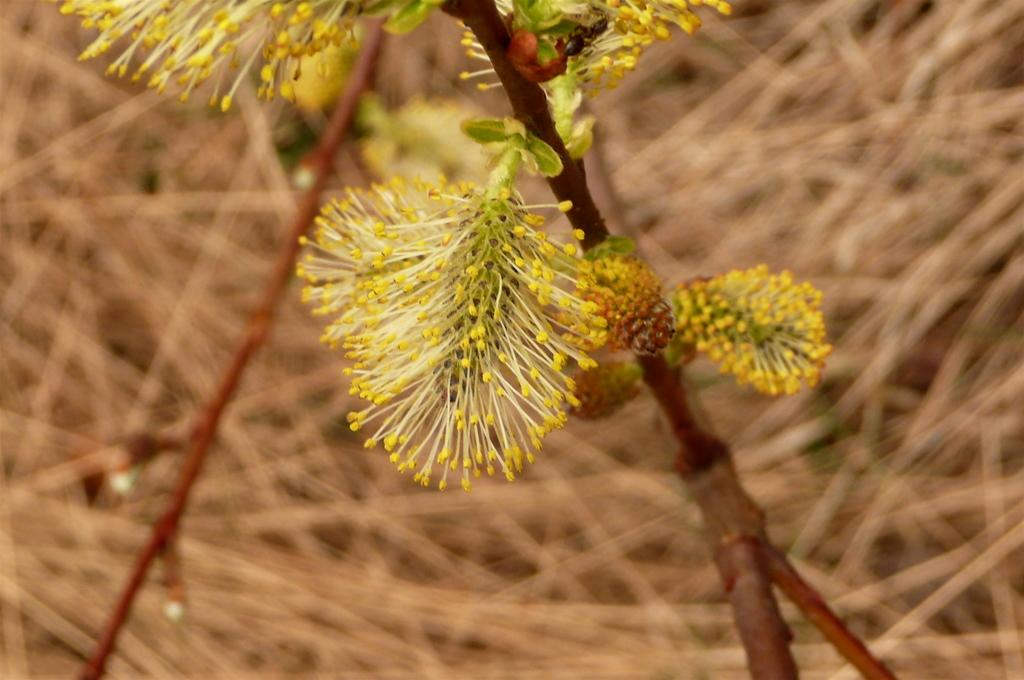What is the main subject of the image? There is a plant in the image. What color are the flowers on the plant? The plant has yellow flowers. Can you describe the background of the image? The background of the image is blurred. What type of meat can be seen hanging from the plant in the image? There is no meat present in the image; it features a plant with yellow flowers. How does the plant show respect to the viewer in the image? Plants do not have the ability to show respect, as they are inanimate objects. 